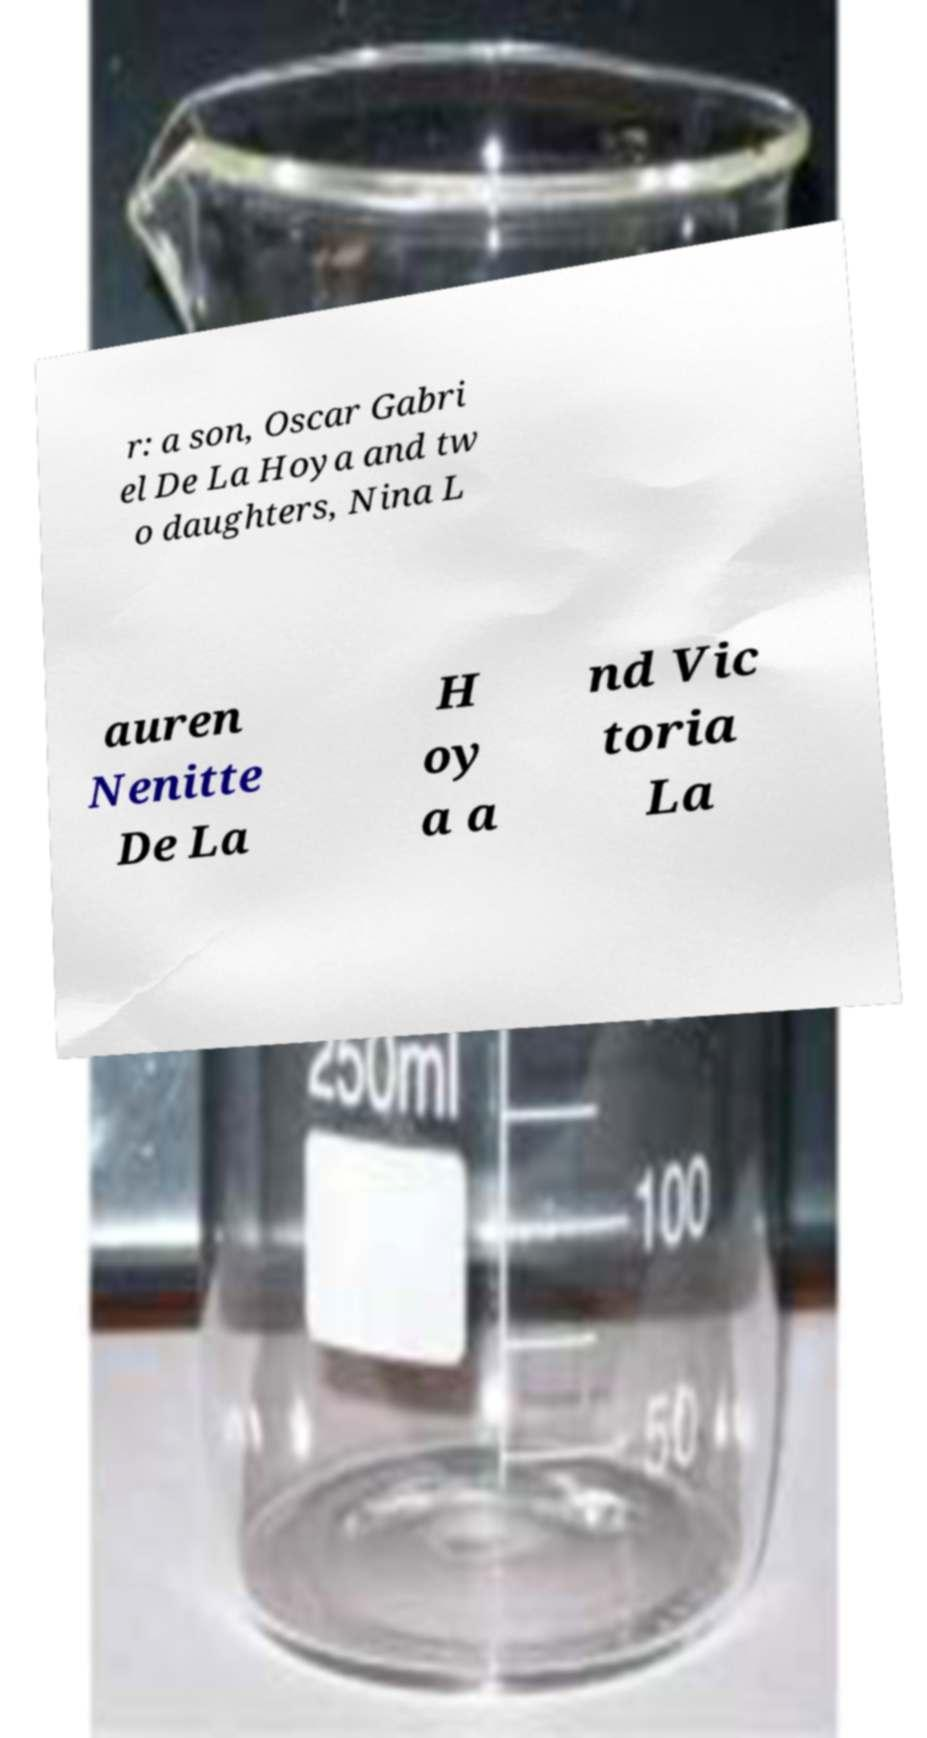Please identify and transcribe the text found in this image. r: a son, Oscar Gabri el De La Hoya and tw o daughters, Nina L auren Nenitte De La H oy a a nd Vic toria La 